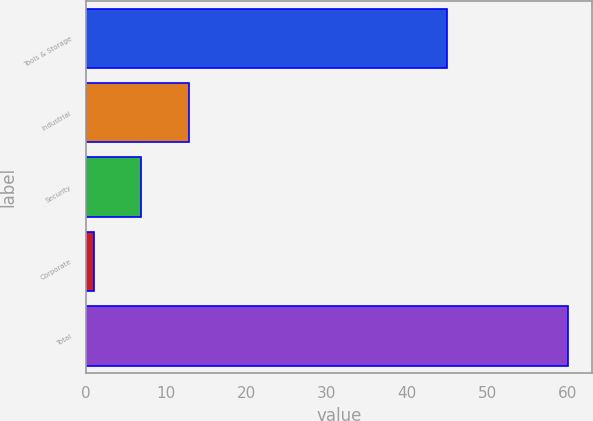Convert chart to OTSL. <chart><loc_0><loc_0><loc_500><loc_500><bar_chart><fcel>Tools & Storage<fcel>Industrial<fcel>Security<fcel>Corporate<fcel>Total<nl><fcel>45<fcel>12.8<fcel>6.9<fcel>1<fcel>60<nl></chart> 